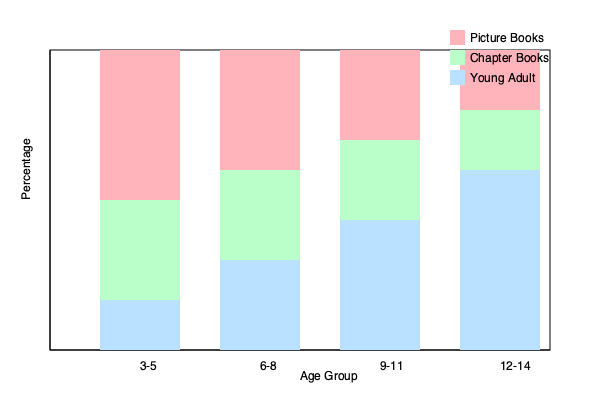As a parent who reads to your child at bedtime, you've noticed changes in their book preferences over time. The graph shows the relationship between children's age groups and their preferred book genres. What trend can be observed in the popularity of Young Adult books as children grow older, and how might this impact your bedtime reading routine? To answer this question, we need to analyze the trend of Young Adult books (represented by the blue bars) across the age groups:

1. Age 3-5: Young Adult books occupy approximately 16.7% of the bar (50/300).
2. Age 6-8: Young Adult books occupy approximately 30% of the bar (90/300).
3. Age 9-11: Young Adult books occupy approximately 43.3% of the bar (130/300).
4. Age 12-14: Young Adult books occupy approximately 60% of the bar (180/300).

We can observe a clear increasing trend in the popularity of Young Adult books as children grow older. The percentage of children preferring Young Adult books increases steadily from 16.7% in the 3-5 age group to 60% in the 12-14 age group.

This trend would impact the bedtime reading routine in several ways:

1. Book selection: As the child grows older, parents would need to gradually introduce more Young Adult books into the bedtime reading selection.

2. Reading time: Young Adult books are typically longer and more complex than picture books or early chapter books, potentially extending the bedtime reading session.

3. Content complexity: The themes and vocabulary in Young Adult books are more advanced, which might require more explanation and discussion during reading time.

4. Shared reading experience: As children become more proficient readers, the bedtime routine might evolve from parents reading aloud to shared reading or independent reading followed by discussion.

5. Transition period: The graph shows overlapping preferences, indicating that children might enjoy a mix of genres during transition periods between age groups.
Answer: Young Adult book popularity increases with age, necessitating gradual changes in book selection, reading time, and complexity of bedtime reading routine. 